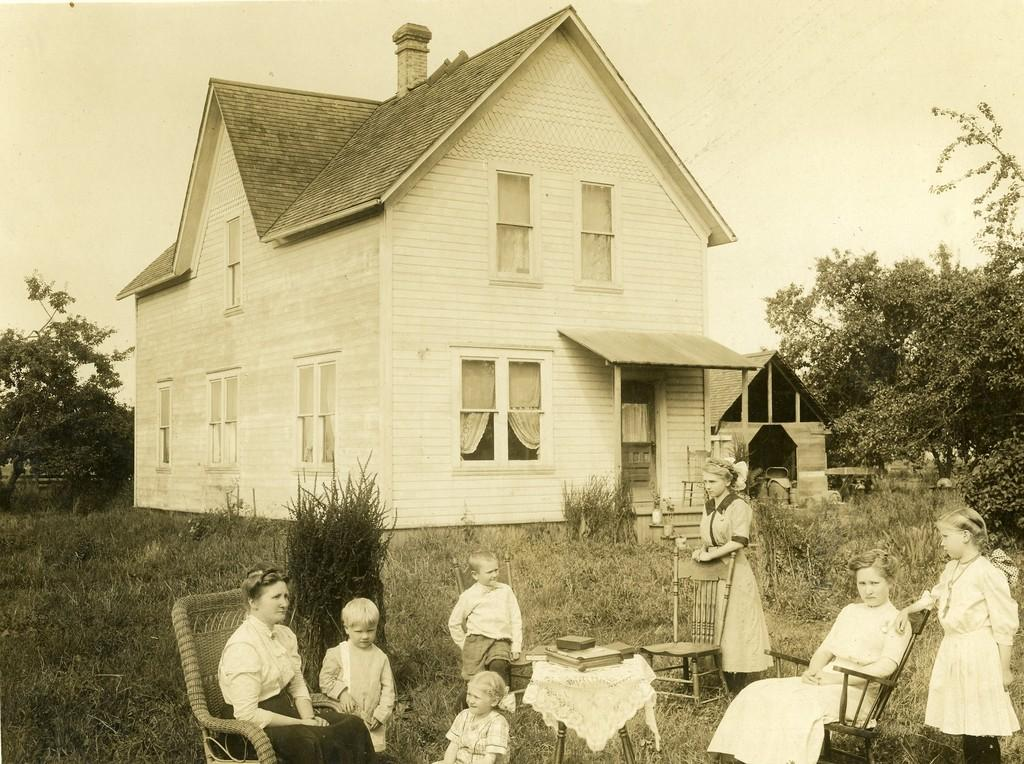What are the people in the image doing? The people in the image are sitting. What can be seen in the background of the image? There is a building in the background of the image. What type of insurance policy do the people in the image have? There is no information about insurance policies in the image. 